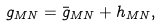<formula> <loc_0><loc_0><loc_500><loc_500>g _ { M N } = \bar { g } _ { M N } + h _ { M N } ,</formula> 